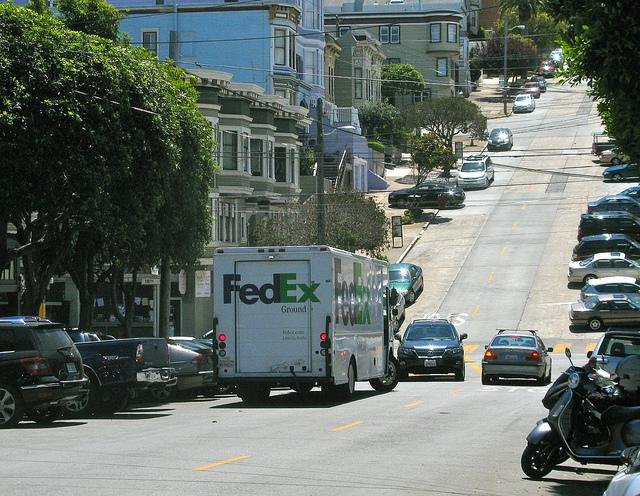Which car is in greatest danger if the FedEx car rushed forward? suv 